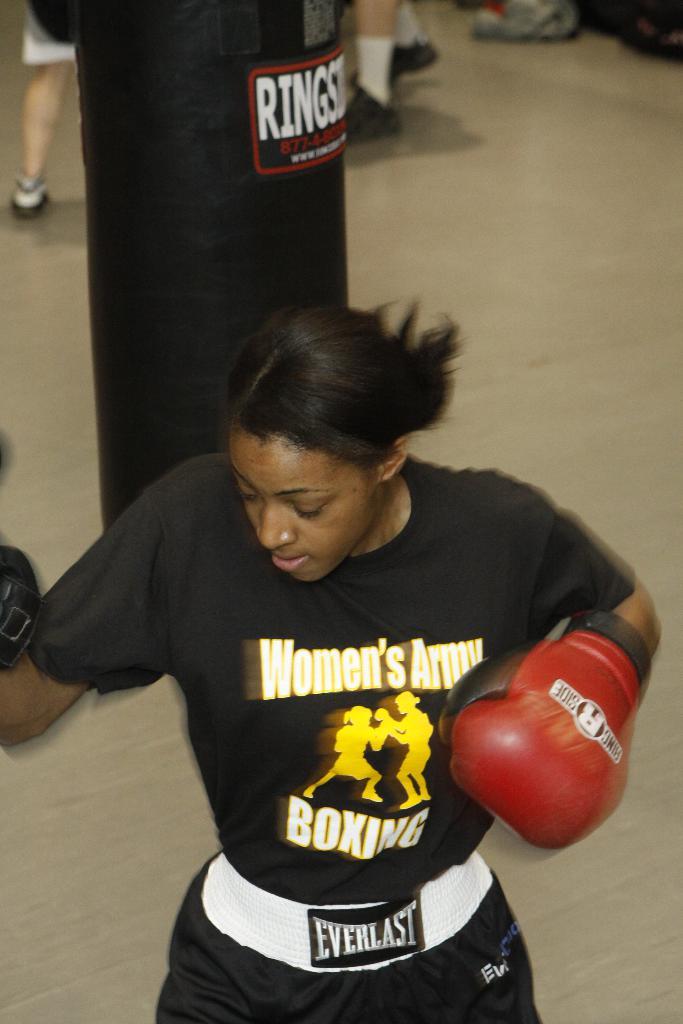What branch of the military is the shirt designated for?
Your answer should be compact. Army. What brand is the pants?
Make the answer very short. Everlast. 